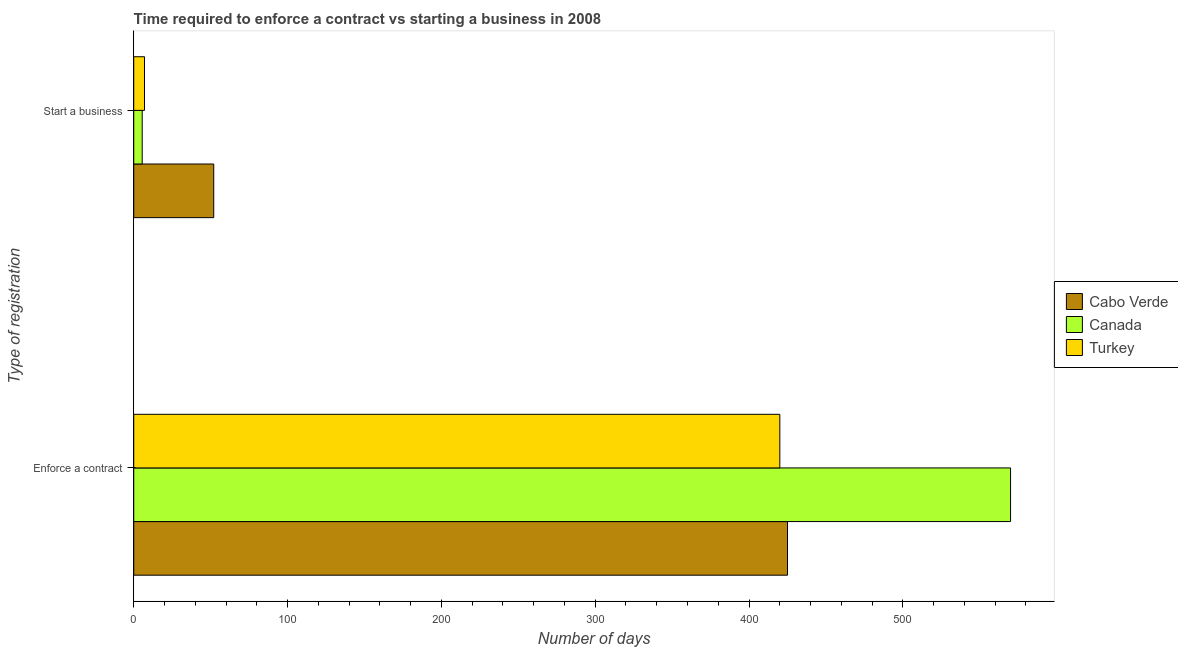How many different coloured bars are there?
Ensure brevity in your answer.  3. What is the label of the 1st group of bars from the top?
Give a very brief answer. Start a business. Across all countries, what is the minimum number of days to start a business?
Keep it short and to the point. 5.5. What is the total number of days to enforece a contract in the graph?
Your response must be concise. 1415. What is the difference between the number of days to enforece a contract in Turkey and that in Canada?
Ensure brevity in your answer.  -150. What is the difference between the number of days to enforece a contract in Cabo Verde and the number of days to start a business in Turkey?
Provide a short and direct response. 418. What is the difference between the number of days to enforece a contract and number of days to start a business in Canada?
Your response must be concise. 564.5. What is the ratio of the number of days to enforece a contract in Cabo Verde to that in Canada?
Keep it short and to the point. 0.75. Is the number of days to enforece a contract in Turkey less than that in Canada?
Ensure brevity in your answer.  Yes. What does the 1st bar from the top in Enforce a contract represents?
Provide a succinct answer. Turkey. What does the 3rd bar from the bottom in Enforce a contract represents?
Offer a terse response. Turkey. How many bars are there?
Offer a very short reply. 6. Are all the bars in the graph horizontal?
Provide a short and direct response. Yes. What is the difference between two consecutive major ticks on the X-axis?
Make the answer very short. 100. Are the values on the major ticks of X-axis written in scientific E-notation?
Make the answer very short. No. How many legend labels are there?
Your response must be concise. 3. How are the legend labels stacked?
Ensure brevity in your answer.  Vertical. What is the title of the graph?
Ensure brevity in your answer.  Time required to enforce a contract vs starting a business in 2008. What is the label or title of the X-axis?
Ensure brevity in your answer.  Number of days. What is the label or title of the Y-axis?
Provide a succinct answer. Type of registration. What is the Number of days in Cabo Verde in Enforce a contract?
Ensure brevity in your answer.  425. What is the Number of days of Canada in Enforce a contract?
Offer a terse response. 570. What is the Number of days in Turkey in Enforce a contract?
Your answer should be very brief. 420. What is the Number of days in Cabo Verde in Start a business?
Ensure brevity in your answer.  52. What is the Number of days of Turkey in Start a business?
Your answer should be very brief. 7. Across all Type of registration, what is the maximum Number of days in Cabo Verde?
Your answer should be very brief. 425. Across all Type of registration, what is the maximum Number of days of Canada?
Keep it short and to the point. 570. Across all Type of registration, what is the maximum Number of days in Turkey?
Give a very brief answer. 420. What is the total Number of days of Cabo Verde in the graph?
Offer a very short reply. 477. What is the total Number of days of Canada in the graph?
Offer a very short reply. 575.5. What is the total Number of days in Turkey in the graph?
Your answer should be compact. 427. What is the difference between the Number of days of Cabo Verde in Enforce a contract and that in Start a business?
Offer a terse response. 373. What is the difference between the Number of days of Canada in Enforce a contract and that in Start a business?
Keep it short and to the point. 564.5. What is the difference between the Number of days in Turkey in Enforce a contract and that in Start a business?
Offer a very short reply. 413. What is the difference between the Number of days of Cabo Verde in Enforce a contract and the Number of days of Canada in Start a business?
Your answer should be very brief. 419.5. What is the difference between the Number of days in Cabo Verde in Enforce a contract and the Number of days in Turkey in Start a business?
Offer a very short reply. 418. What is the difference between the Number of days of Canada in Enforce a contract and the Number of days of Turkey in Start a business?
Your answer should be very brief. 563. What is the average Number of days in Cabo Verde per Type of registration?
Make the answer very short. 238.5. What is the average Number of days in Canada per Type of registration?
Ensure brevity in your answer.  287.75. What is the average Number of days in Turkey per Type of registration?
Give a very brief answer. 213.5. What is the difference between the Number of days of Cabo Verde and Number of days of Canada in Enforce a contract?
Provide a short and direct response. -145. What is the difference between the Number of days in Cabo Verde and Number of days in Turkey in Enforce a contract?
Provide a short and direct response. 5. What is the difference between the Number of days of Canada and Number of days of Turkey in Enforce a contract?
Give a very brief answer. 150. What is the difference between the Number of days in Cabo Verde and Number of days in Canada in Start a business?
Your answer should be compact. 46.5. What is the difference between the Number of days of Cabo Verde and Number of days of Turkey in Start a business?
Give a very brief answer. 45. What is the difference between the Number of days of Canada and Number of days of Turkey in Start a business?
Ensure brevity in your answer.  -1.5. What is the ratio of the Number of days of Cabo Verde in Enforce a contract to that in Start a business?
Make the answer very short. 8.17. What is the ratio of the Number of days in Canada in Enforce a contract to that in Start a business?
Ensure brevity in your answer.  103.64. What is the difference between the highest and the second highest Number of days in Cabo Verde?
Your answer should be very brief. 373. What is the difference between the highest and the second highest Number of days in Canada?
Your response must be concise. 564.5. What is the difference between the highest and the second highest Number of days of Turkey?
Your answer should be very brief. 413. What is the difference between the highest and the lowest Number of days in Cabo Verde?
Your answer should be very brief. 373. What is the difference between the highest and the lowest Number of days in Canada?
Your answer should be very brief. 564.5. What is the difference between the highest and the lowest Number of days of Turkey?
Provide a short and direct response. 413. 